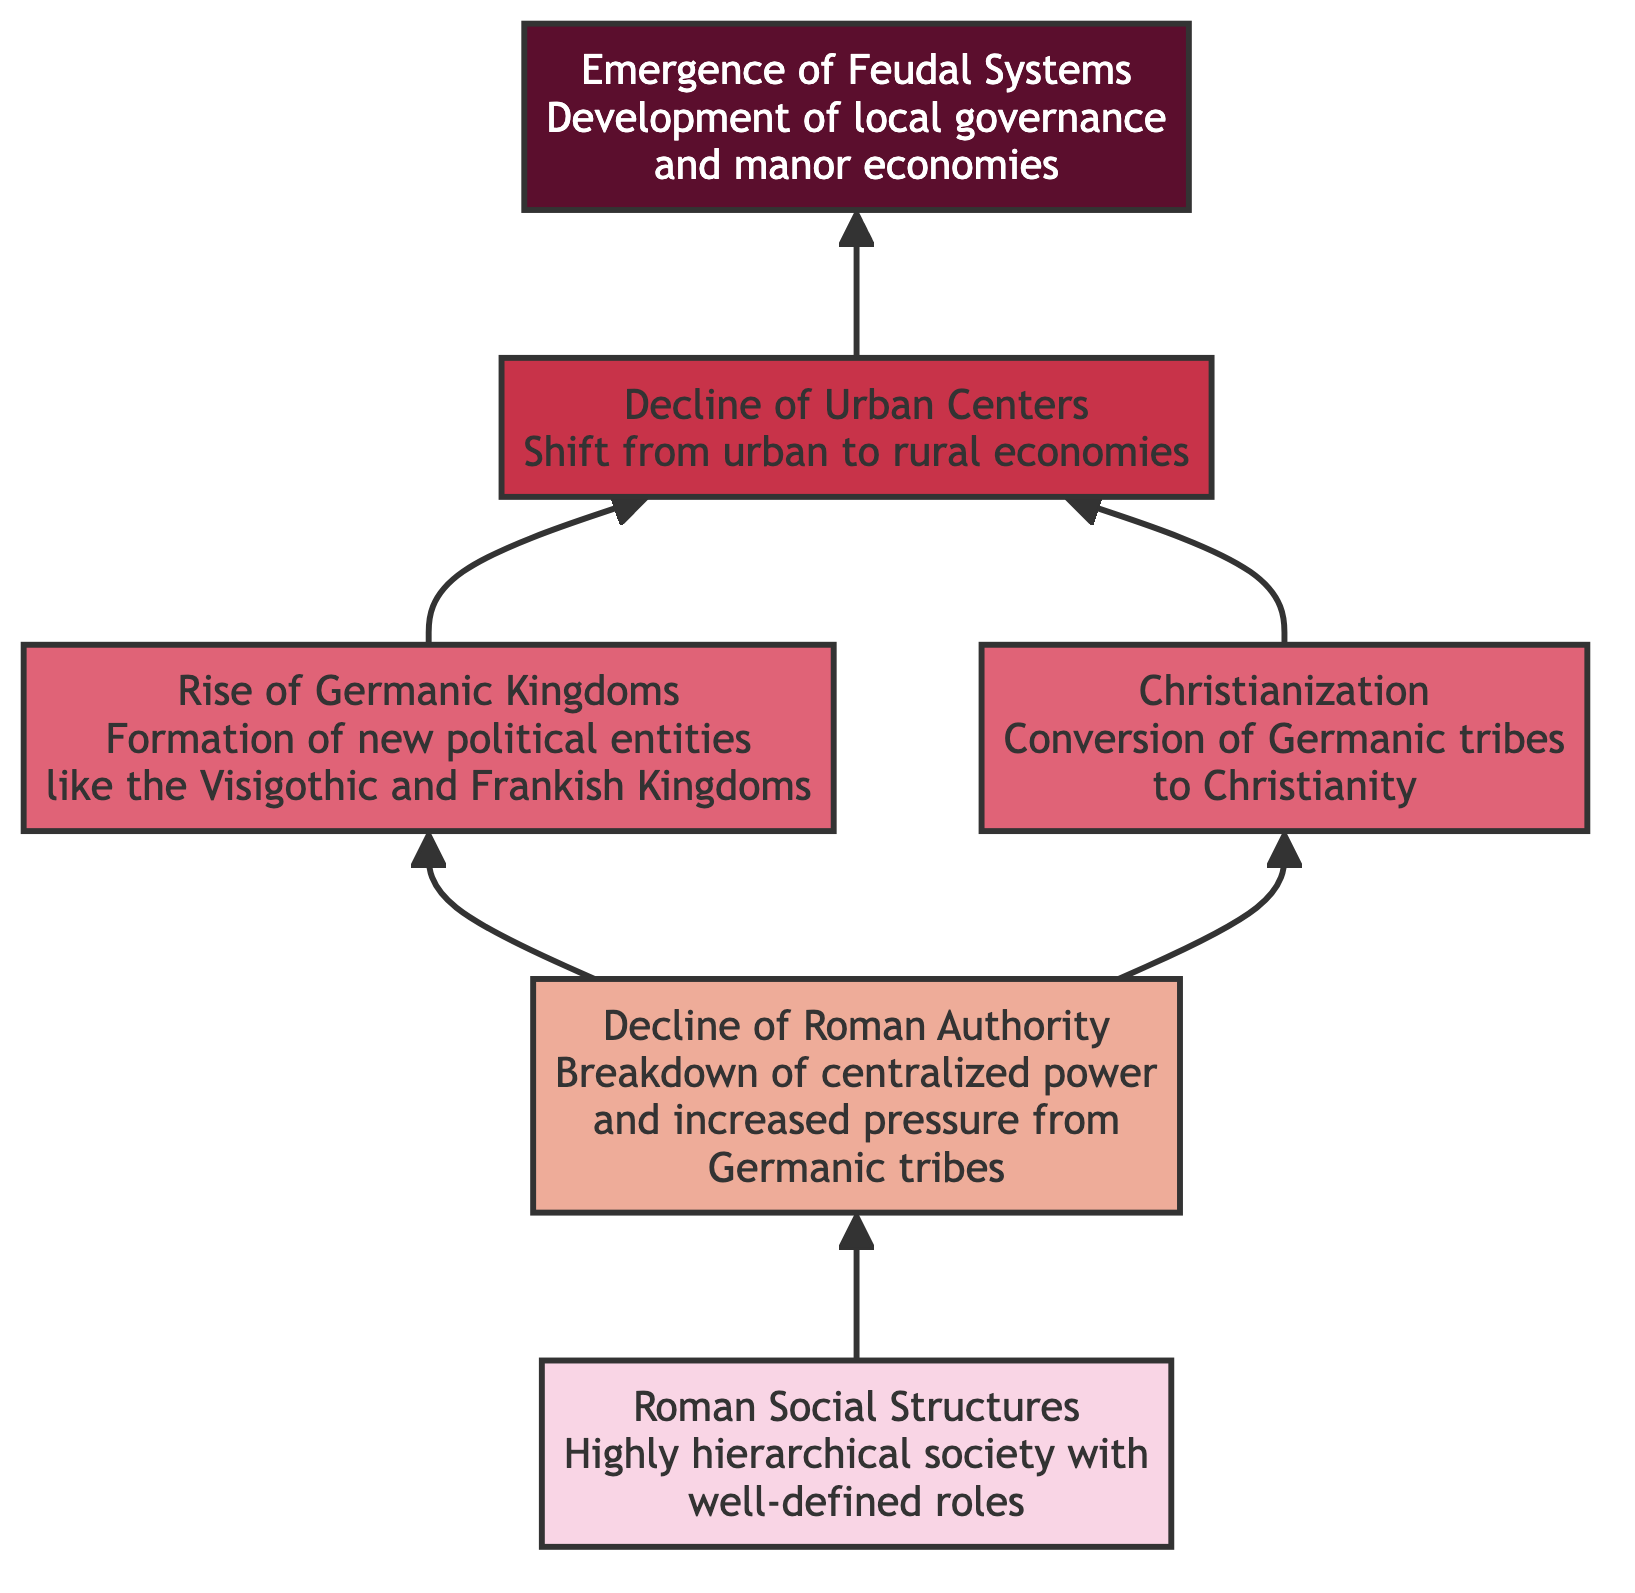What is the top node in the diagram? The top node is the highest point in the flowchart, which represents the final outcome of the societal changes, listed as "Emergence of Feudal Systems."
Answer: Emergence of Feudal Systems How many nodes are present in the diagram? Counting all the unique elements within the flowchart, there are six nodes representing distinct stages in societal changes.
Answer: 6 What connects Roman Social Structures to Decline of Roman Authority? The arrow pointing directly from "Roman Social Structures" to "Decline of Roman Authority" indicates a direct transition showing that the former's hierarchical structures contributed to the latter's breakdown.
Answer: Decline of Roman Authority Which two factors led to the Decline of Urban Centers? The "Rise of Germanic Kingdoms" and "Christianization" both lead into the "Decline of Urban Centers," showing that both influenced the shift from urban to rural economies.
Answer: Rise of Germanic Kingdoms and Christianization What is the relationship between Christianization and the Emergence of Feudal Systems? "Christianization" serves as a contributing factor to the "Emergence of Feudal Systems," as the influence of the Church played a role in establishing local governance.
Answer: Contributes to Which element directly influences the Emergence of Feudal Systems? The only direct predecessor of "Emergence of Feudal Systems" in the diagram is "Decline of Urban Centers," which indicates a significant change leading to feudal governance structures.
Answer: Decline of Urban Centers Are there more nodes in the Mid-tier or Upper Mid-tier? There are two nodes in the Mid-tier ("Rise of Germanic Kingdoms" and "Christianization") and one in the Upper Mid-tier ("Decline of Urban Centers"). Thus, Mid-tier has more nodes.
Answer: Mid-tier What is the defining characteristic of the Roman Social Structures at the base? The diagram describes it as a "highly hierarchical society with well-defined roles," indicating a structured social order.
Answer: Highly hierarchical society What happens to the population distribution as urban centers decline? The transition from urban to rural economies as indicated by the arrow pointing from "Decline of Urban Centers" leads to a decrease in urban populations.
Answer: Decrease in urban populations 